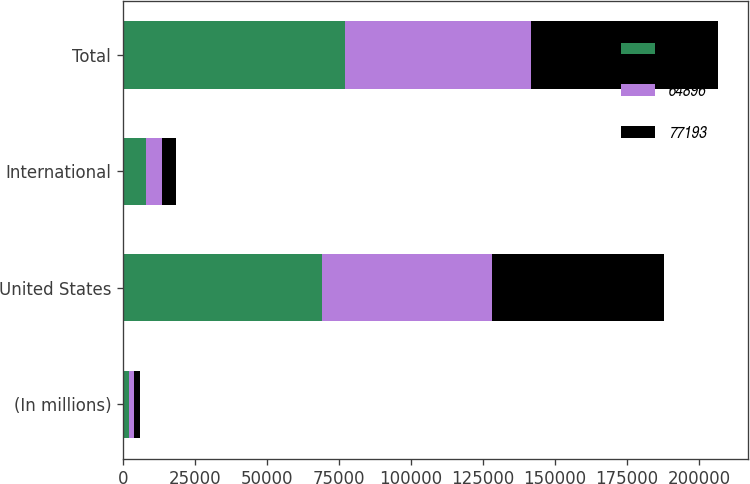Convert chart to OTSL. <chart><loc_0><loc_0><loc_500><loc_500><stacked_bar_chart><ecel><fcel>(In millions)<fcel>United States<fcel>International<fcel>Total<nl><fcel>64552<fcel>2008<fcel>69034<fcel>8159<fcel>77193<nl><fcel>64896<fcel>2007<fcel>59302<fcel>5250<fcel>64552<nl><fcel>77193<fcel>2006<fcel>59723<fcel>5173<fcel>64896<nl></chart> 